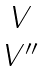<formula> <loc_0><loc_0><loc_500><loc_500>\begin{matrix} V \\ V ^ { \prime \prime } \end{matrix}</formula> 